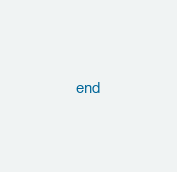<code> <loc_0><loc_0><loc_500><loc_500><_Ruby_>end
</code> 